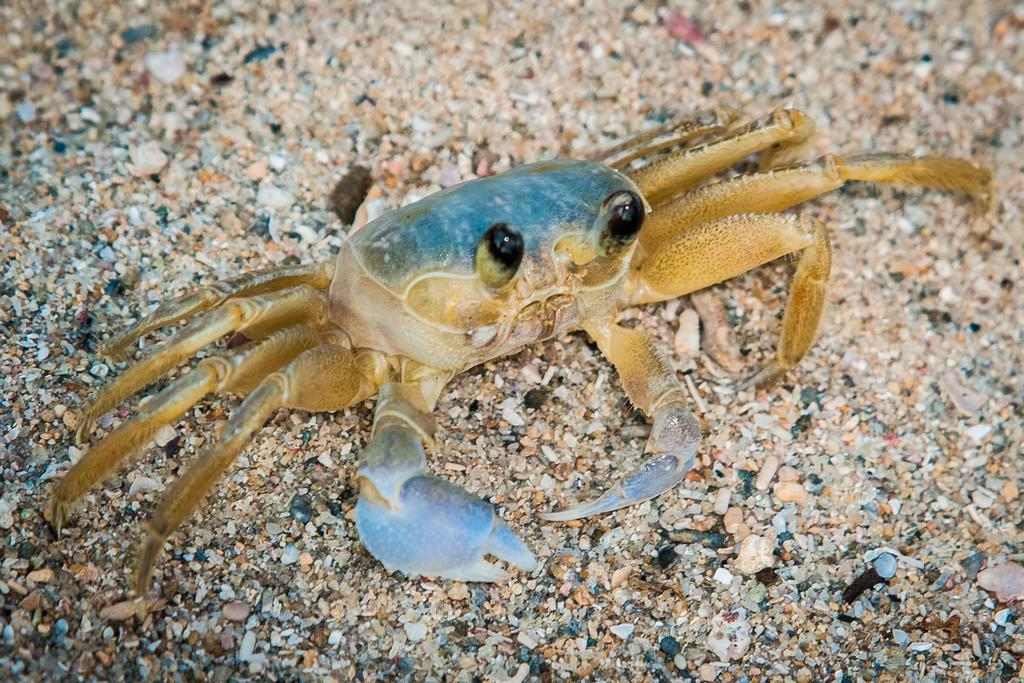What is the main subject of the picture? The main subject of the picture is a crab. Where is the crab located in the picture? The crab is on the land in the picture. Can you describe the position of the crab in the picture? The crab is in the middle of the picture. What colors can be seen on the crab? The crab has blue and brown colors. What type of branch can be seen growing out of the crab's shell in the image? There is no branch growing out of the crab's shell in the image. What discovery was made by the crab in the image? There is no indication of a discovery made by the crab in the image. 